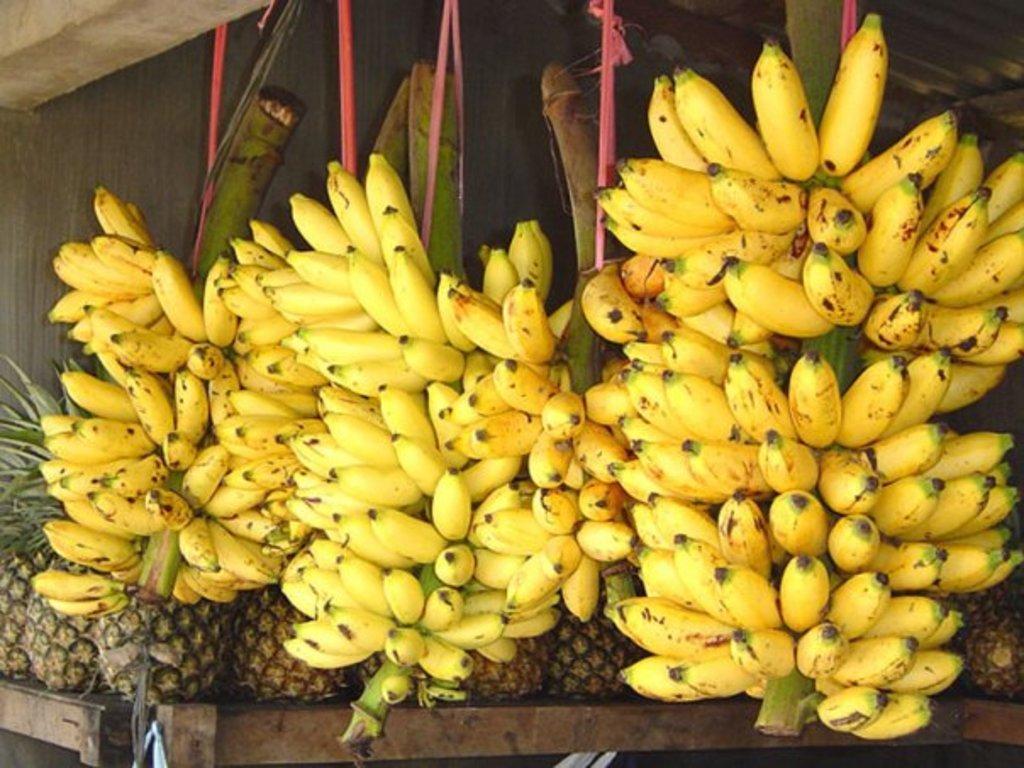Please provide a concise description of this image. In this image, we can see bananas. There are pineapples on the table. 